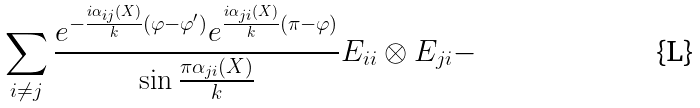<formula> <loc_0><loc_0><loc_500><loc_500>\sum _ { i \neq j } \frac { e ^ { - \frac { i \alpha _ { i j } ( X ) } { k } ( \varphi - \varphi ^ { \prime } ) } e ^ { \frac { i \alpha _ { j i } ( X ) } { k } ( \pi - \varphi ) } } { \sin { \frac { \pi \alpha _ { j i } ( X ) } { k } } } E _ { i i } \otimes E _ { j i } -</formula> 